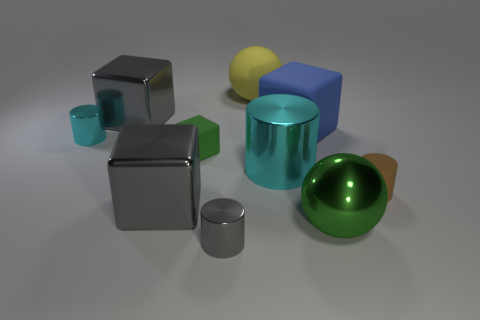Is the number of big gray objects in front of the small brown thing less than the number of gray shiny things in front of the green matte object?
Give a very brief answer. Yes. There is a green thing behind the matte object right of the large green object; what is its shape?
Your answer should be compact. Cube. Are there any other things that are the same color as the metal ball?
Give a very brief answer. Yes. Do the tiny block and the metal sphere have the same color?
Your answer should be very brief. Yes. What number of yellow objects are rubber balls or tiny rubber objects?
Your response must be concise. 1. Is the number of large cyan metal things to the right of the large green shiny ball less than the number of large gray shiny things?
Offer a very short reply. Yes. There is a block that is in front of the small rubber cylinder; what number of big gray metal things are on the left side of it?
Offer a very short reply. 1. How many other objects are there of the same size as the blue matte object?
Provide a short and direct response. 5. How many objects are big gray things or blocks in front of the big blue object?
Offer a very short reply. 3. Is the number of large gray objects less than the number of large blocks?
Offer a very short reply. Yes. 